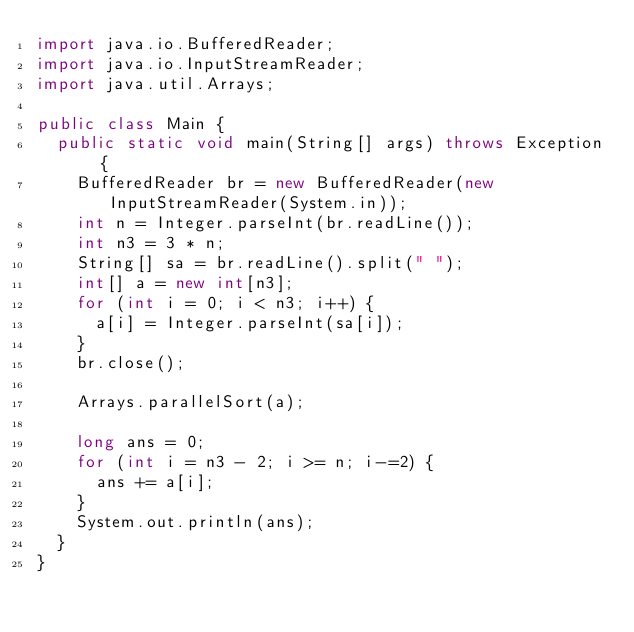Convert code to text. <code><loc_0><loc_0><loc_500><loc_500><_Java_>import java.io.BufferedReader;
import java.io.InputStreamReader;
import java.util.Arrays;

public class Main {
	public static void main(String[] args) throws Exception {
		BufferedReader br = new BufferedReader(new InputStreamReader(System.in));
		int n = Integer.parseInt(br.readLine());
		int n3 = 3 * n;
		String[] sa = br.readLine().split(" ");
		int[] a = new int[n3];
		for (int i = 0; i < n3; i++) {
			a[i] = Integer.parseInt(sa[i]);
		}
		br.close();

		Arrays.parallelSort(a);

		long ans = 0;
		for (int i = n3 - 2; i >= n; i-=2) {
			ans += a[i];
		}
		System.out.println(ans);
	}
}
</code> 